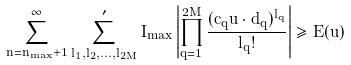Convert formula to latex. <formula><loc_0><loc_0><loc_500><loc_500>\sum _ { n = n _ { \max } + 1 } ^ { \infty } \sum _ { l _ { 1 } , l _ { 2 } , \dots , l _ { 2 M } } ^ { \prime } I _ { \max } \left | \prod _ { q = 1 } ^ { 2 M } \frac { ( c _ { q } \vec { u } \cdot \vec { d } _ { q } ) ^ { l _ { q } } } { l _ { q } ! } \right | \geq E ( \vec { u } )</formula> 